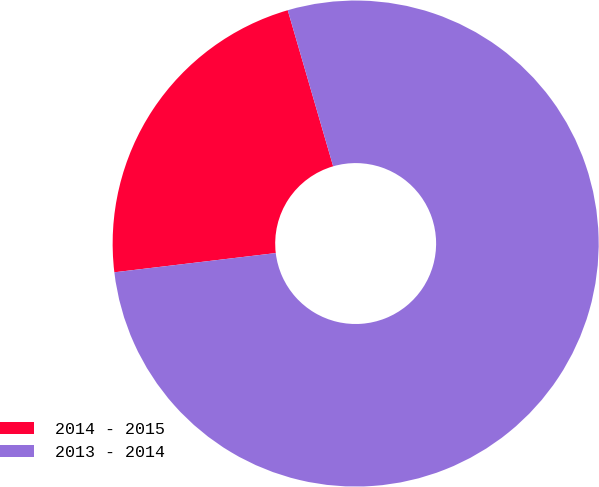<chart> <loc_0><loc_0><loc_500><loc_500><pie_chart><fcel>2014 - 2015<fcel>2013 - 2014<nl><fcel>22.38%<fcel>77.62%<nl></chart> 